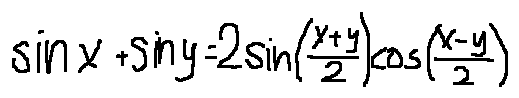Convert formula to latex. <formula><loc_0><loc_0><loc_500><loc_500>\sin x + \sin y = 2 \sin ( \frac { x + y } { 2 } ) \cos ( \frac { x - y } { 2 } )</formula> 